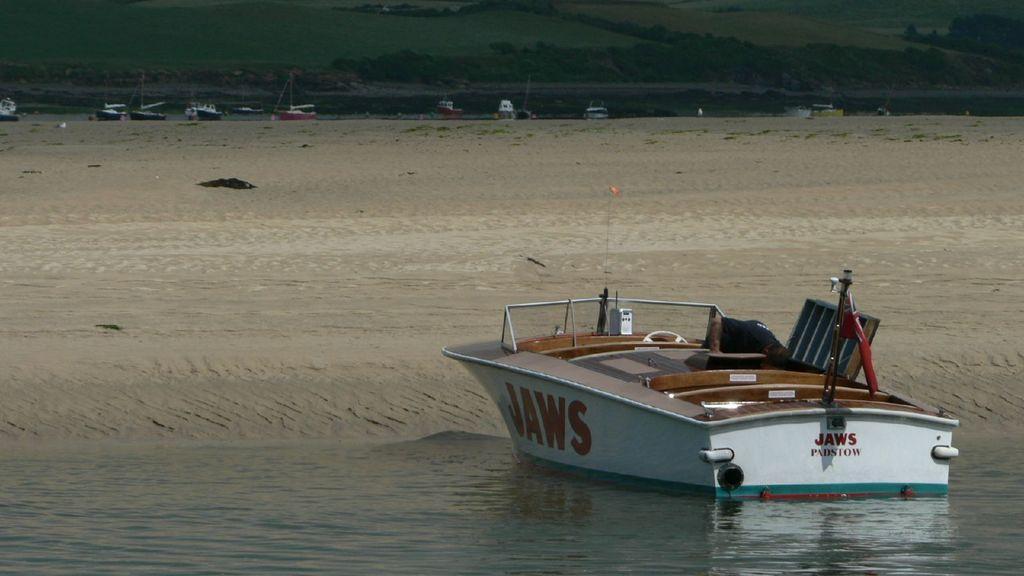Could you give a brief overview of what you see in this image? In this image there is a boat on the water. There is text on the walls of the boat. Behind it there is sand on the ground. In the background there are boats and hills. 